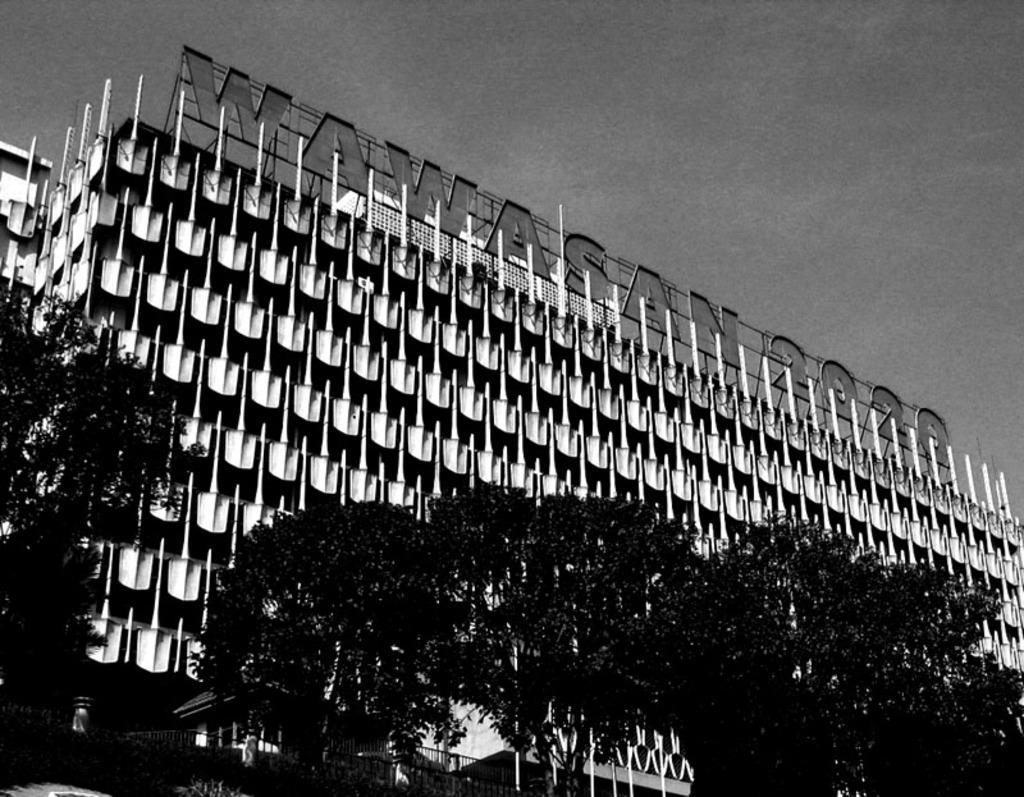Please provide a concise description of this image. This picture is an black and white image. In this image, we can see some trees, buildings. On the top, we can see a sky. 